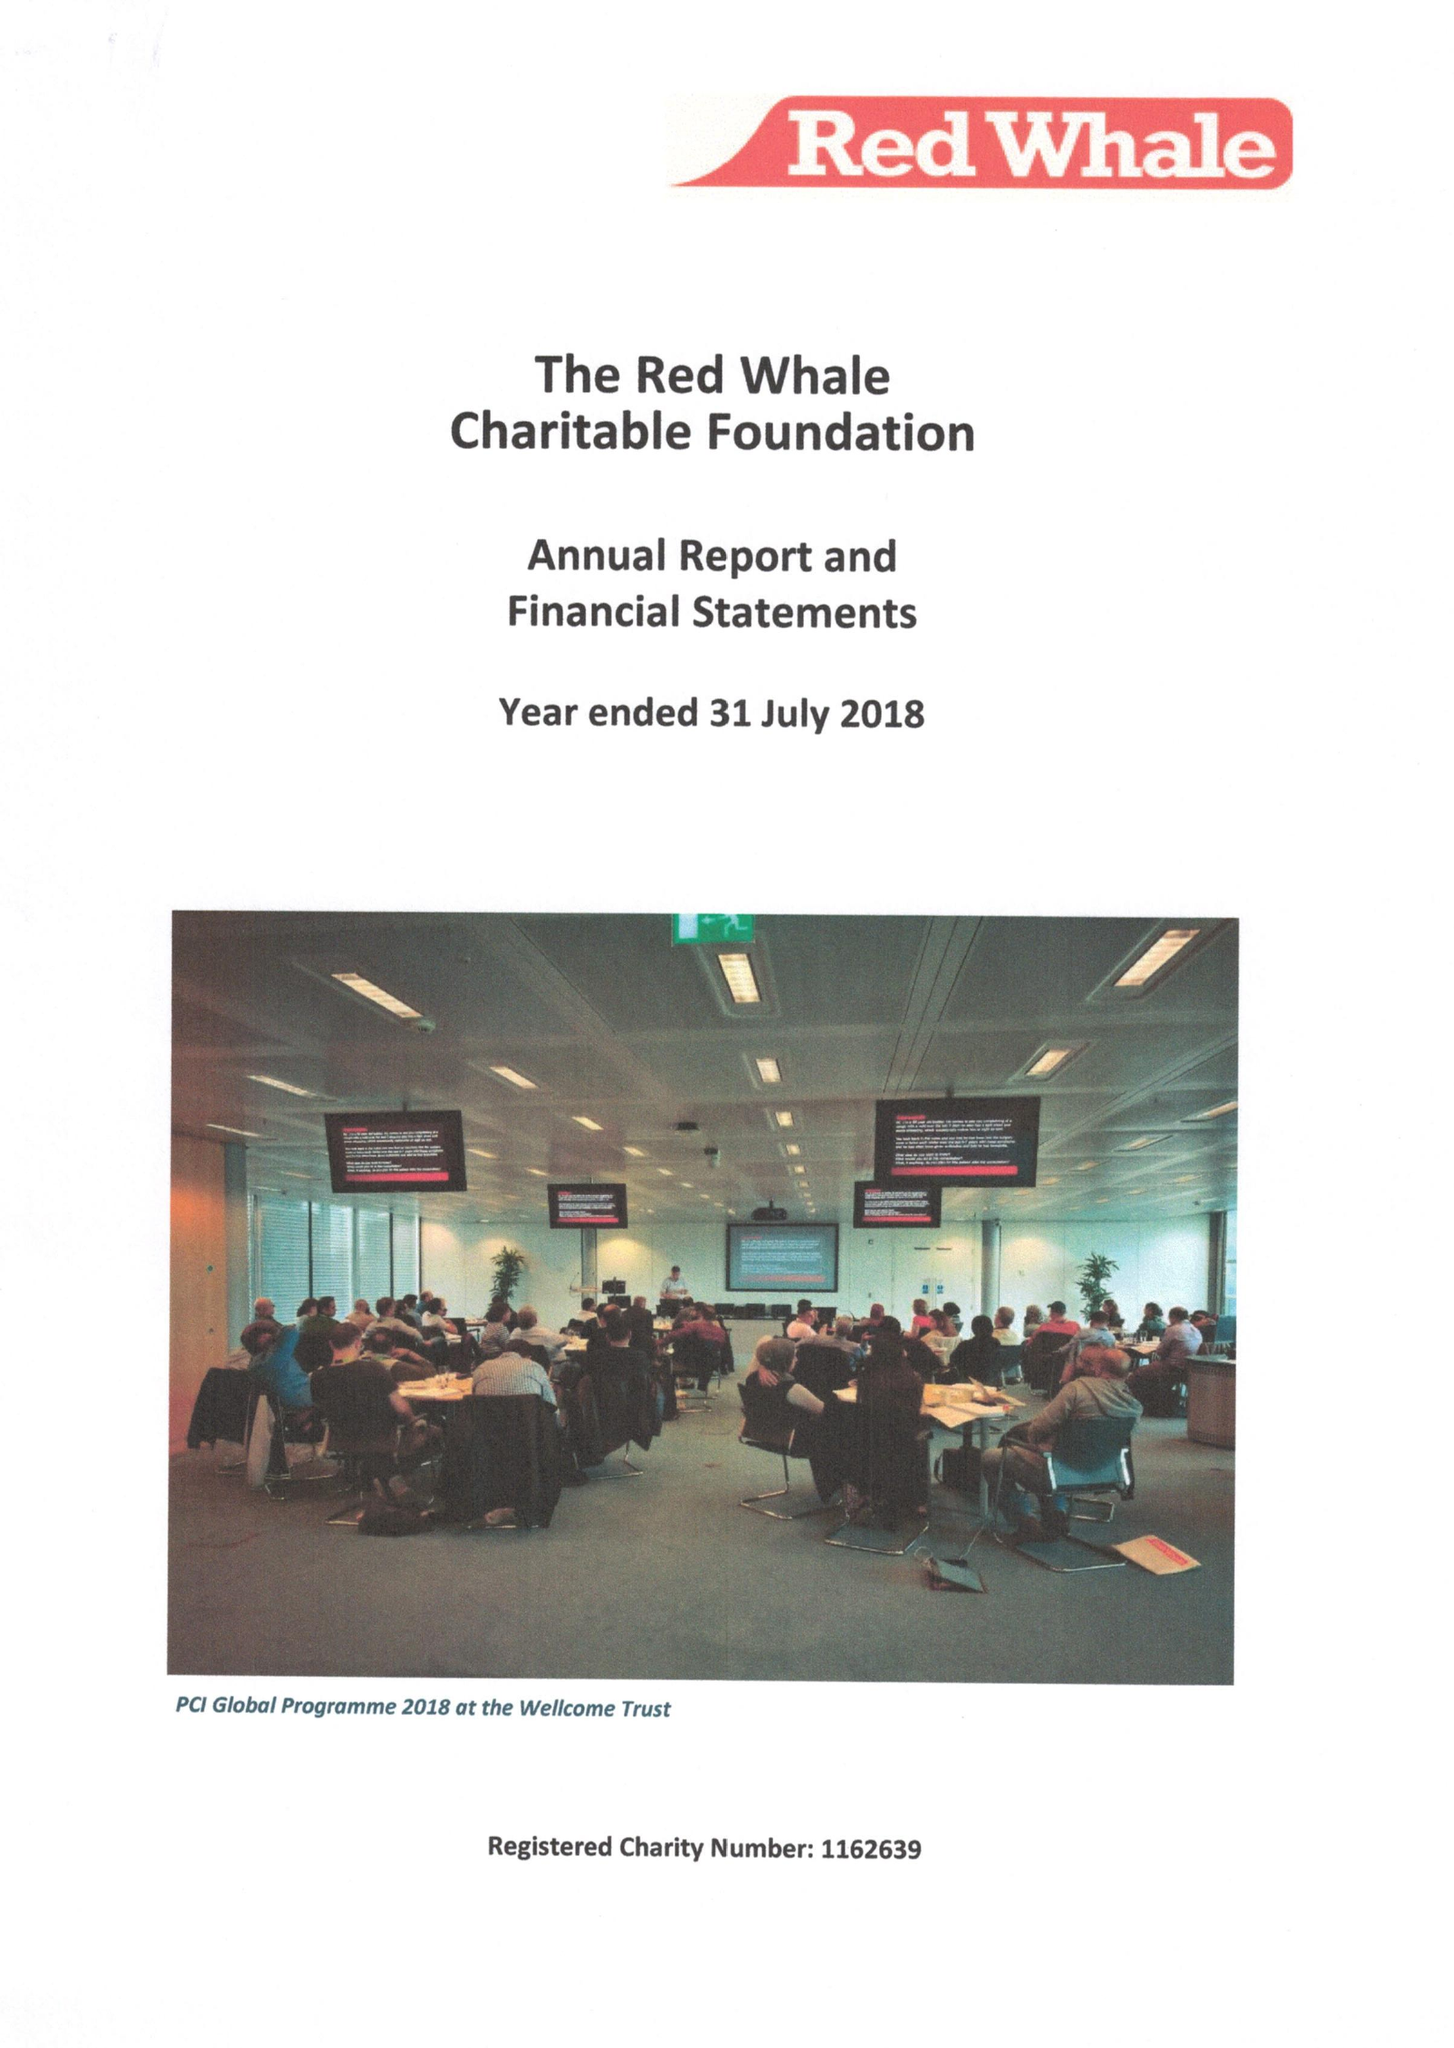What is the value for the address__postcode?
Answer the question using a single word or phrase. RG6 6BU 